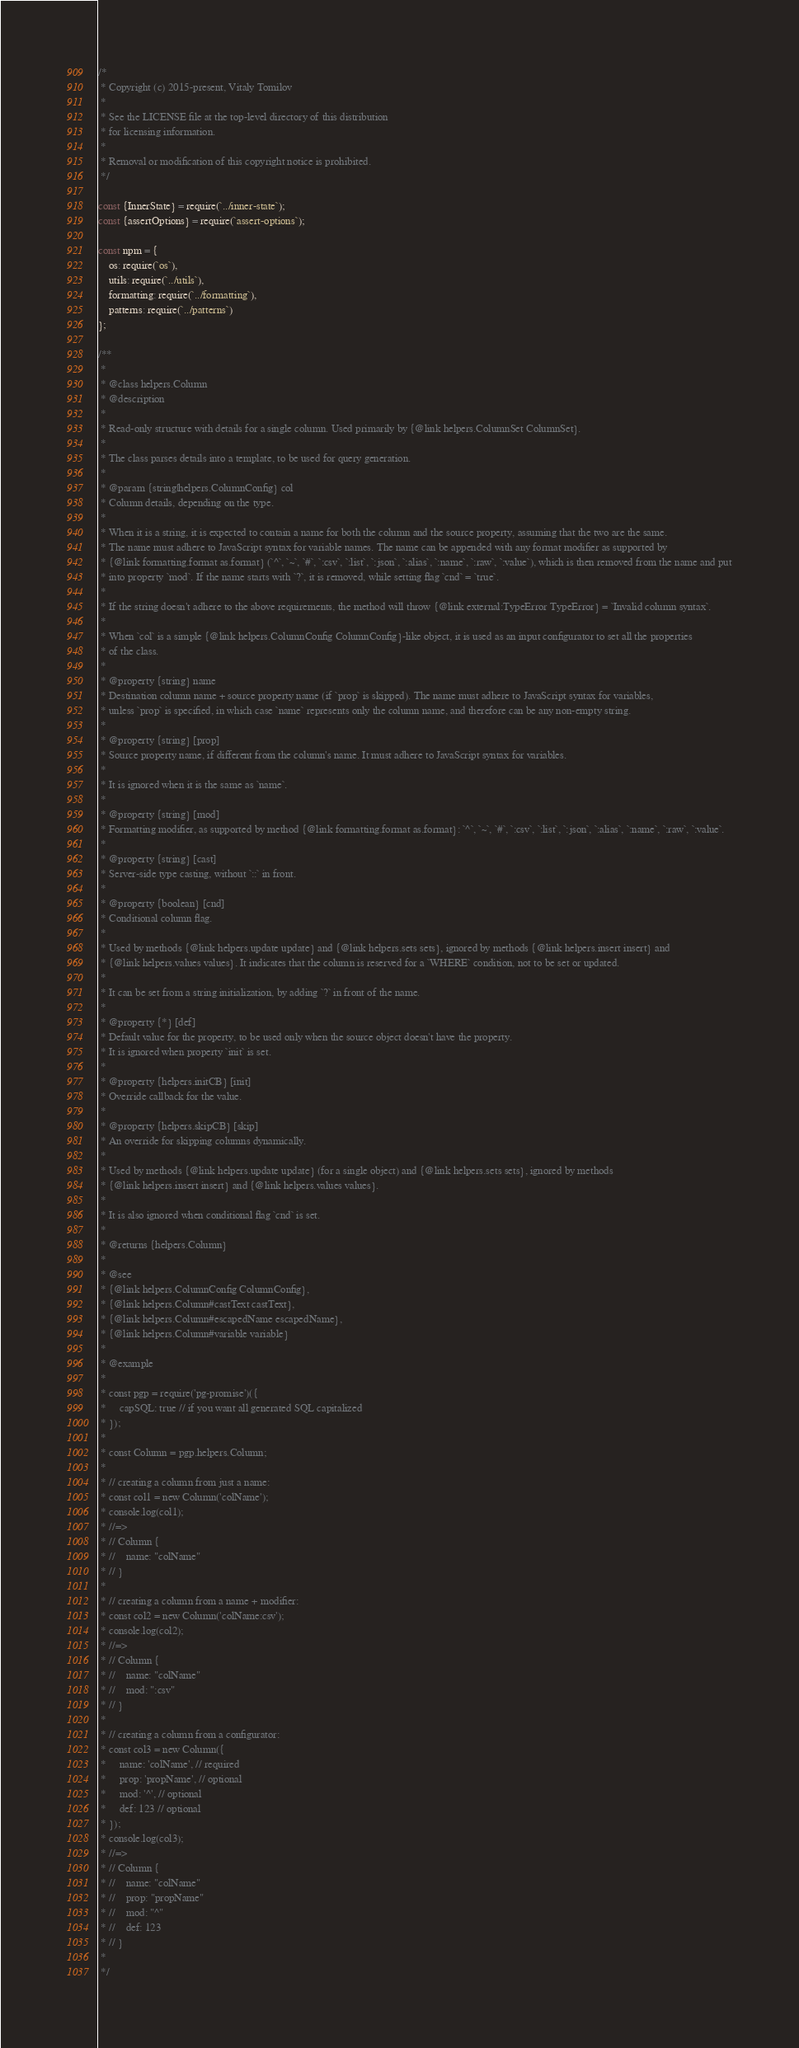Convert code to text. <code><loc_0><loc_0><loc_500><loc_500><_JavaScript_>/*
 * Copyright (c) 2015-present, Vitaly Tomilov
 *
 * See the LICENSE file at the top-level directory of this distribution
 * for licensing information.
 *
 * Removal or modification of this copyright notice is prohibited.
 */

const {InnerState} = require(`../inner-state`);
const {assertOptions} = require(`assert-options`);

const npm = {
    os: require(`os`),
    utils: require(`../utils`),
    formatting: require(`../formatting`),
    patterns: require(`../patterns`)
};

/**
 *
 * @class helpers.Column
 * @description
 *
 * Read-only structure with details for a single column. Used primarily by {@link helpers.ColumnSet ColumnSet}.
 *
 * The class parses details into a template, to be used for query generation.
 *
 * @param {string|helpers.ColumnConfig} col
 * Column details, depending on the type.
 *
 * When it is a string, it is expected to contain a name for both the column and the source property, assuming that the two are the same.
 * The name must adhere to JavaScript syntax for variable names. The name can be appended with any format modifier as supported by
 * {@link formatting.format as.format} (`^`, `~`, `#`, `:csv`, `:list`, `:json`, `:alias`, `:name`, `:raw`, `:value`), which is then removed from the name and put
 * into property `mod`. If the name starts with `?`, it is removed, while setting flag `cnd` = `true`.
 *
 * If the string doesn't adhere to the above requirements, the method will throw {@link external:TypeError TypeError} = `Invalid column syntax`.
 *
 * When `col` is a simple {@link helpers.ColumnConfig ColumnConfig}-like object, it is used as an input configurator to set all the properties
 * of the class.
 *
 * @property {string} name
 * Destination column name + source property name (if `prop` is skipped). The name must adhere to JavaScript syntax for variables,
 * unless `prop` is specified, in which case `name` represents only the column name, and therefore can be any non-empty string.
 *
 * @property {string} [prop]
 * Source property name, if different from the column's name. It must adhere to JavaScript syntax for variables.
 *
 * It is ignored when it is the same as `name`.
 *
 * @property {string} [mod]
 * Formatting modifier, as supported by method {@link formatting.format as.format}: `^`, `~`, `#`, `:csv`, `:list`, `:json`, `:alias`, `:name`, `:raw`, `:value`.
 *
 * @property {string} [cast]
 * Server-side type casting, without `::` in front.
 *
 * @property {boolean} [cnd]
 * Conditional column flag.
 *
 * Used by methods {@link helpers.update update} and {@link helpers.sets sets}, ignored by methods {@link helpers.insert insert} and
 * {@link helpers.values values}. It indicates that the column is reserved for a `WHERE` condition, not to be set or updated.
 *
 * It can be set from a string initialization, by adding `?` in front of the name.
 *
 * @property {*} [def]
 * Default value for the property, to be used only when the source object doesn't have the property.
 * It is ignored when property `init` is set.
 *
 * @property {helpers.initCB} [init]
 * Override callback for the value.
 *
 * @property {helpers.skipCB} [skip]
 * An override for skipping columns dynamically.
 *
 * Used by methods {@link helpers.update update} (for a single object) and {@link helpers.sets sets}, ignored by methods
 * {@link helpers.insert insert} and {@link helpers.values values}.
 *
 * It is also ignored when conditional flag `cnd` is set.
 *
 * @returns {helpers.Column}
 *
 * @see
 * {@link helpers.ColumnConfig ColumnConfig},
 * {@link helpers.Column#castText castText},
 * {@link helpers.Column#escapedName escapedName},
 * {@link helpers.Column#variable variable}
 *
 * @example
 *
 * const pgp = require('pg-promise')({
 *     capSQL: true // if you want all generated SQL capitalized
 * });
 *
 * const Column = pgp.helpers.Column;
 *
 * // creating a column from just a name:
 * const col1 = new Column('colName');
 * console.log(col1);
 * //=>
 * // Column {
 * //    name: "colName"
 * // }
 *
 * // creating a column from a name + modifier:
 * const col2 = new Column('colName:csv');
 * console.log(col2);
 * //=>
 * // Column {
 * //    name: "colName"
 * //    mod: ":csv"
 * // }
 *
 * // creating a column from a configurator:
 * const col3 = new Column({
 *     name: 'colName', // required
 *     prop: 'propName', // optional
 *     mod: '^', // optional
 *     def: 123 // optional
 * });
 * console.log(col3);
 * //=>
 * // Column {
 * //    name: "colName"
 * //    prop: "propName"
 * //    mod: "^"
 * //    def: 123
 * // }
 *
 */</code> 